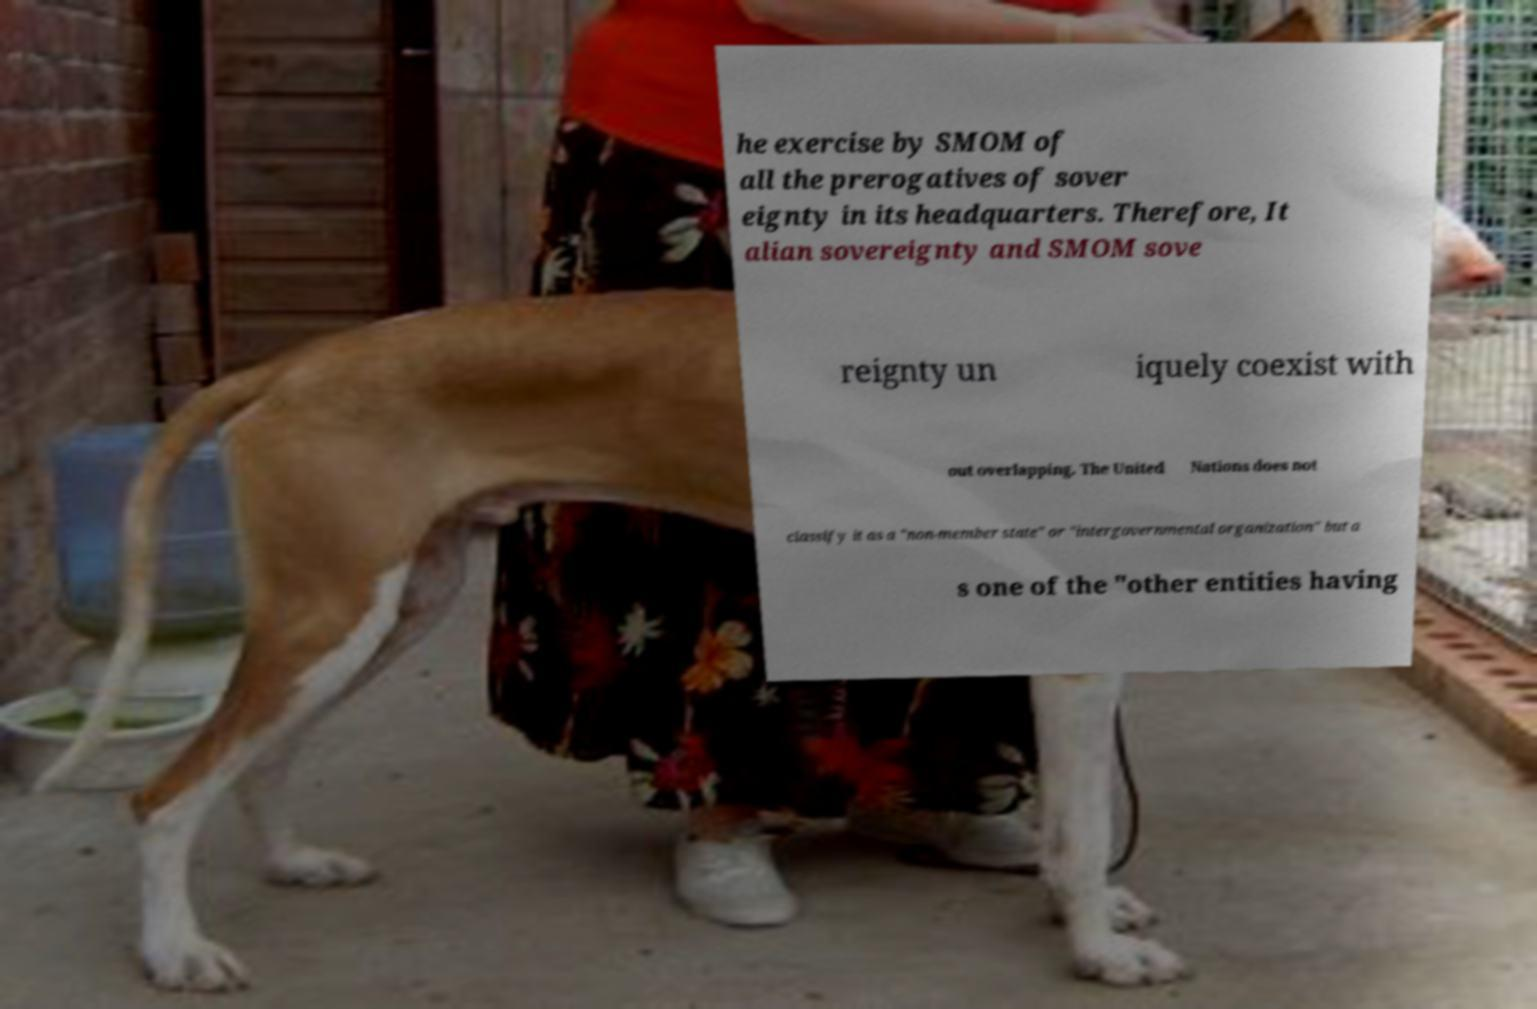Please read and relay the text visible in this image. What does it say? he exercise by SMOM of all the prerogatives of sover eignty in its headquarters. Therefore, It alian sovereignty and SMOM sove reignty un iquely coexist with out overlapping. The United Nations does not classify it as a "non-member state" or "intergovernmental organization" but a s one of the "other entities having 